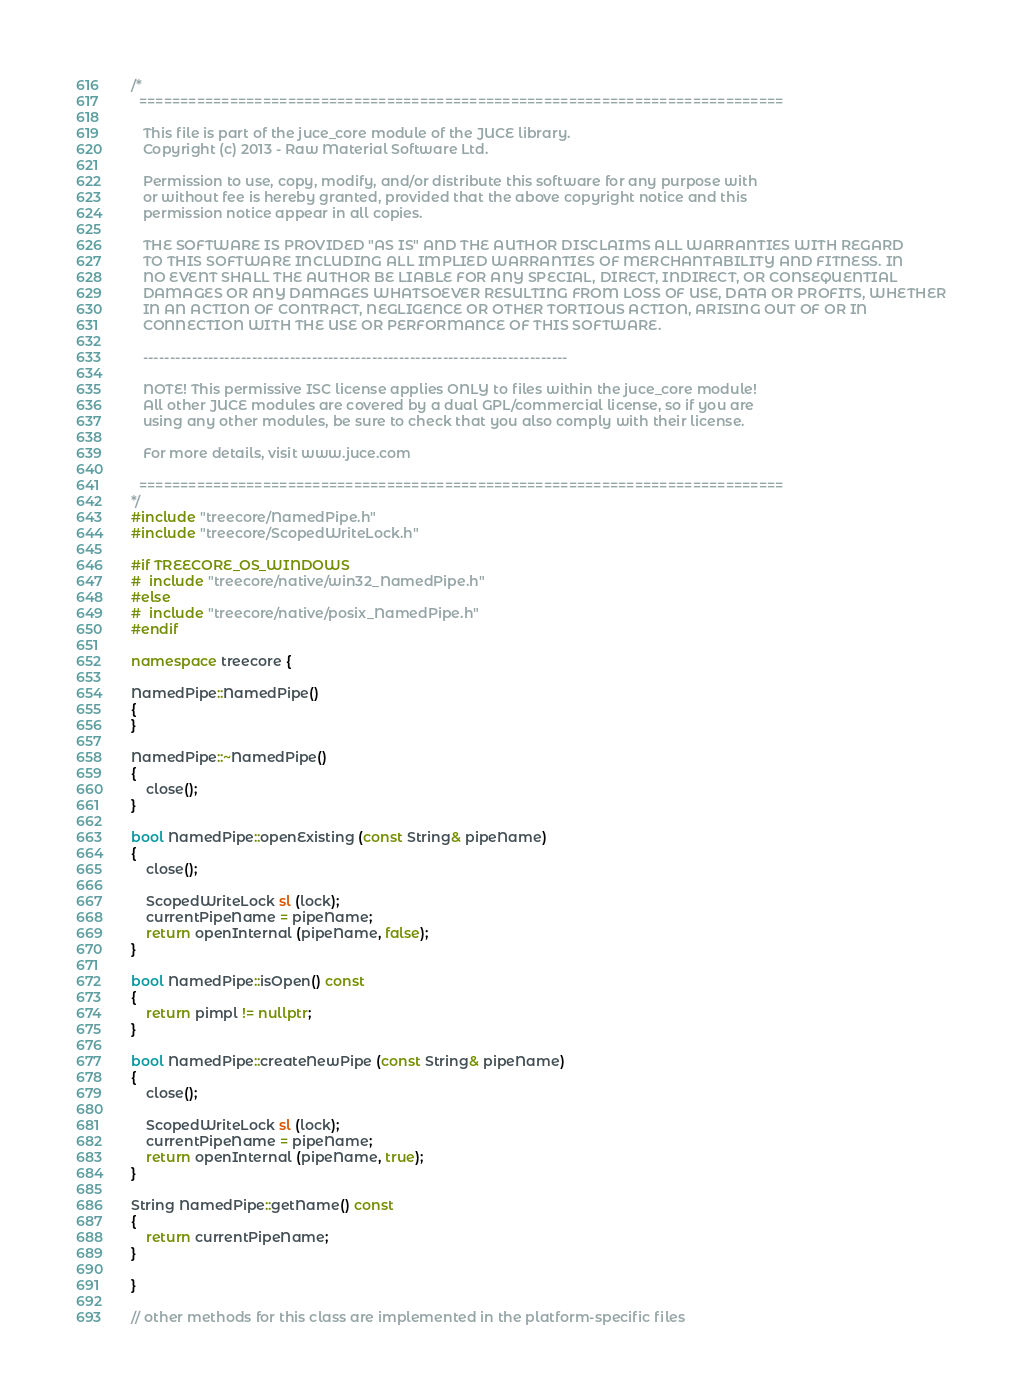Convert code to text. <code><loc_0><loc_0><loc_500><loc_500><_C++_>/*
  ==============================================================================

   This file is part of the juce_core module of the JUCE library.
   Copyright (c) 2013 - Raw Material Software Ltd.

   Permission to use, copy, modify, and/or distribute this software for any purpose with
   or without fee is hereby granted, provided that the above copyright notice and this
   permission notice appear in all copies.

   THE SOFTWARE IS PROVIDED "AS IS" AND THE AUTHOR DISCLAIMS ALL WARRANTIES WITH REGARD
   TO THIS SOFTWARE INCLUDING ALL IMPLIED WARRANTIES OF MERCHANTABILITY AND FITNESS. IN
   NO EVENT SHALL THE AUTHOR BE LIABLE FOR ANY SPECIAL, DIRECT, INDIRECT, OR CONSEQUENTIAL
   DAMAGES OR ANY DAMAGES WHATSOEVER RESULTING FROM LOSS OF USE, DATA OR PROFITS, WHETHER
   IN AN ACTION OF CONTRACT, NEGLIGENCE OR OTHER TORTIOUS ACTION, ARISING OUT OF OR IN
   CONNECTION WITH THE USE OR PERFORMANCE OF THIS SOFTWARE.

   ------------------------------------------------------------------------------

   NOTE! This permissive ISC license applies ONLY to files within the juce_core module!
   All other JUCE modules are covered by a dual GPL/commercial license, so if you are
   using any other modules, be sure to check that you also comply with their license.

   For more details, visit www.juce.com

  ==============================================================================
*/
#include "treecore/NamedPipe.h"
#include "treecore/ScopedWriteLock.h"

#if TREECORE_OS_WINDOWS
#  include "treecore/native/win32_NamedPipe.h"
#else
#  include "treecore/native/posix_NamedPipe.h"
#endif

namespace treecore {

NamedPipe::NamedPipe()
{
}

NamedPipe::~NamedPipe()
{
    close();
}

bool NamedPipe::openExisting (const String& pipeName)
{
    close();

    ScopedWriteLock sl (lock);
    currentPipeName = pipeName;
    return openInternal (pipeName, false);
}

bool NamedPipe::isOpen() const
{
    return pimpl != nullptr;
}

bool NamedPipe::createNewPipe (const String& pipeName)
{
    close();

    ScopedWriteLock sl (lock);
    currentPipeName = pipeName;
    return openInternal (pipeName, true);
}

String NamedPipe::getName() const
{
    return currentPipeName;
}

}

// other methods for this class are implemented in the platform-specific files
</code> 